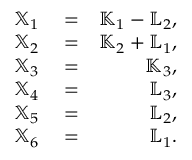<formula> <loc_0><loc_0><loc_500><loc_500>\begin{array} { r l r } { { \mathbb { X } } _ { 1 } } & = } & { { \mathbb { K } } _ { 1 } - { \mathbb { L } } _ { 2 } , } \\ { { \mathbb { X } } _ { 2 } } & = } & { { \mathbb { K } } _ { 2 } + { \mathbb { L } } _ { 1 } , } \\ { { \mathbb { X } } _ { 3 } } & = } & { { \mathbb { K } } _ { 3 } , } \\ { { \mathbb { X } } _ { 4 } } & = } & { { \mathbb { L } } _ { 3 } , } \\ { { \mathbb { X } } _ { 5 } } & = } & { { \mathbb { L } } _ { 2 } , } \\ { { \mathbb { X } } _ { 6 } } & = } & { { \mathbb { L } } _ { 1 } . } \end{array}</formula> 